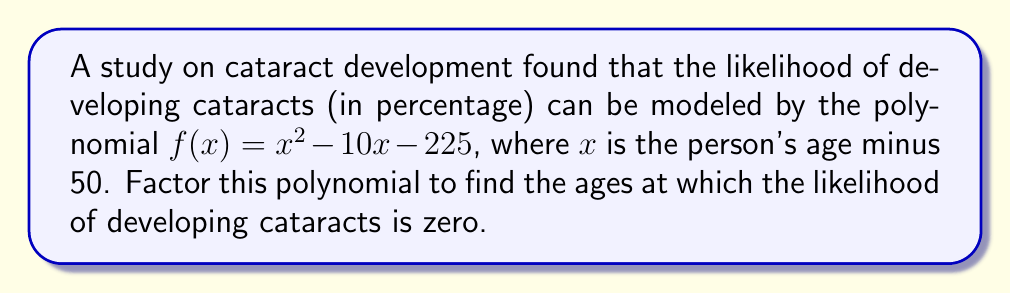Teach me how to tackle this problem. Let's approach this step-by-step:

1) We need to factor the polynomial $f(x) = x^2 - 10x - 225$

2) This is a quadratic equation in the form $ax^2 + bx + c$, where:
   $a = 1$
   $b = -10$
   $c = -225$

3) We can use the quadratic formula or factoring by grouping. Let's use factoring by grouping:

4) First, we need to find two numbers that multiply to give $ac = 1 \times (-225) = -225$ and add up to $b = -10$

5) These numbers are 15 and -25

6) Rewrite the middle term using these numbers:
   $f(x) = x^2 + 15x - 25x - 225$

7) Group the terms:
   $f(x) = (x^2 + 15x) + (-25x - 225)$

8) Factor out the common factors from each group:
   $f(x) = x(x + 15) - 25(x + 9)$

9) Factor out $(x + 15)$:
   $f(x) = (x + 15)(x - 25)$

10) Remember that $x$ is the person's age minus 50. So to find the actual ages, we need to add 50 to our solutions:
    When $x + 15 = 0$, $x = -15$, so age $= -15 + 50 = 35$
    When $x - 25 = 0$, $x = 25$, so age $= 25 + 50 = 75$

Therefore, the likelihood of developing cataracts is zero at ages 35 and 75.
Answer: $(x + 15)(x - 25)$; ages 35 and 75 